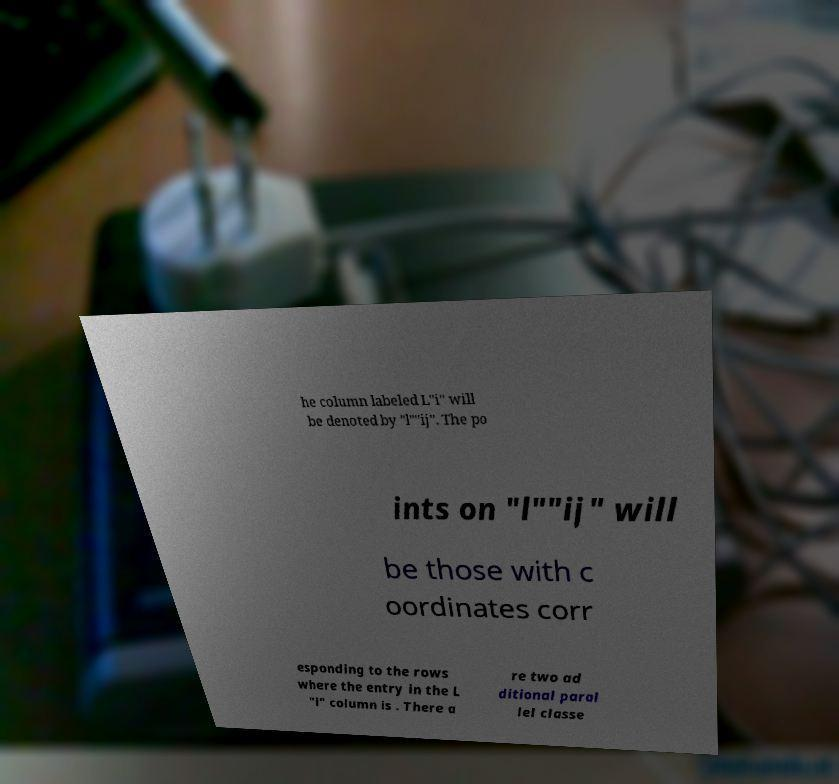Could you extract and type out the text from this image? he column labeled L"i" will be denoted by "l""ij". The po ints on "l""ij" will be those with c oordinates corr esponding to the rows where the entry in the L "i" column is . There a re two ad ditional paral lel classe 